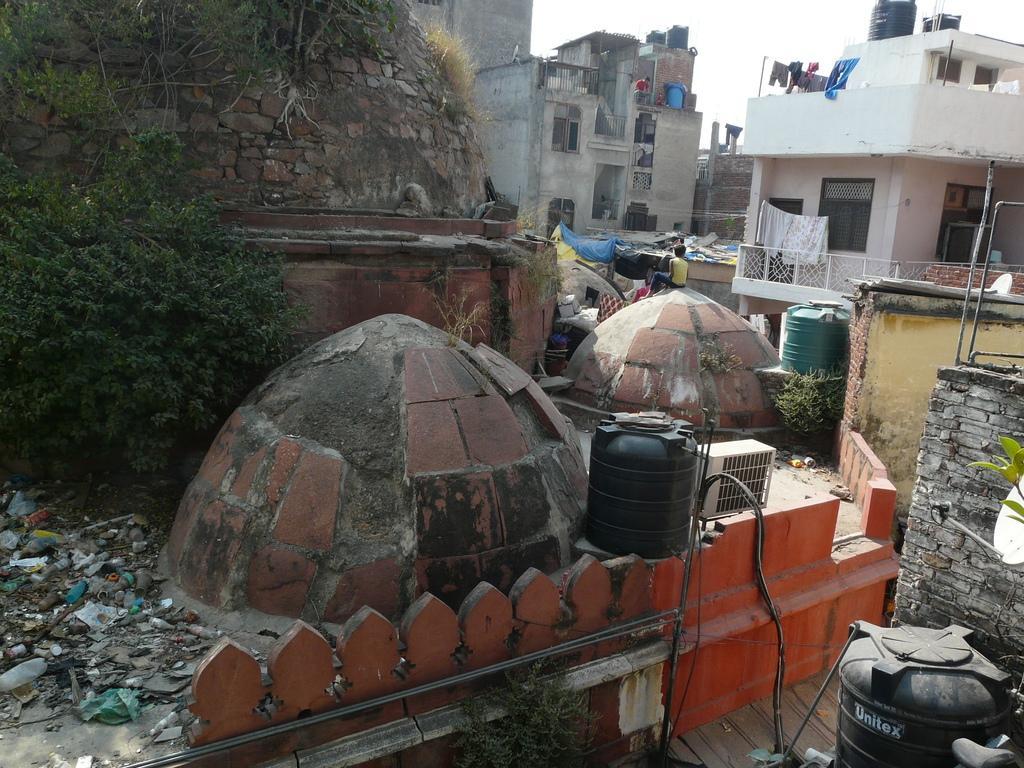Can you describe this image briefly? In this image there are buildings, trees, water tanks, people, clothes, railing, rocks, sky and objects. 